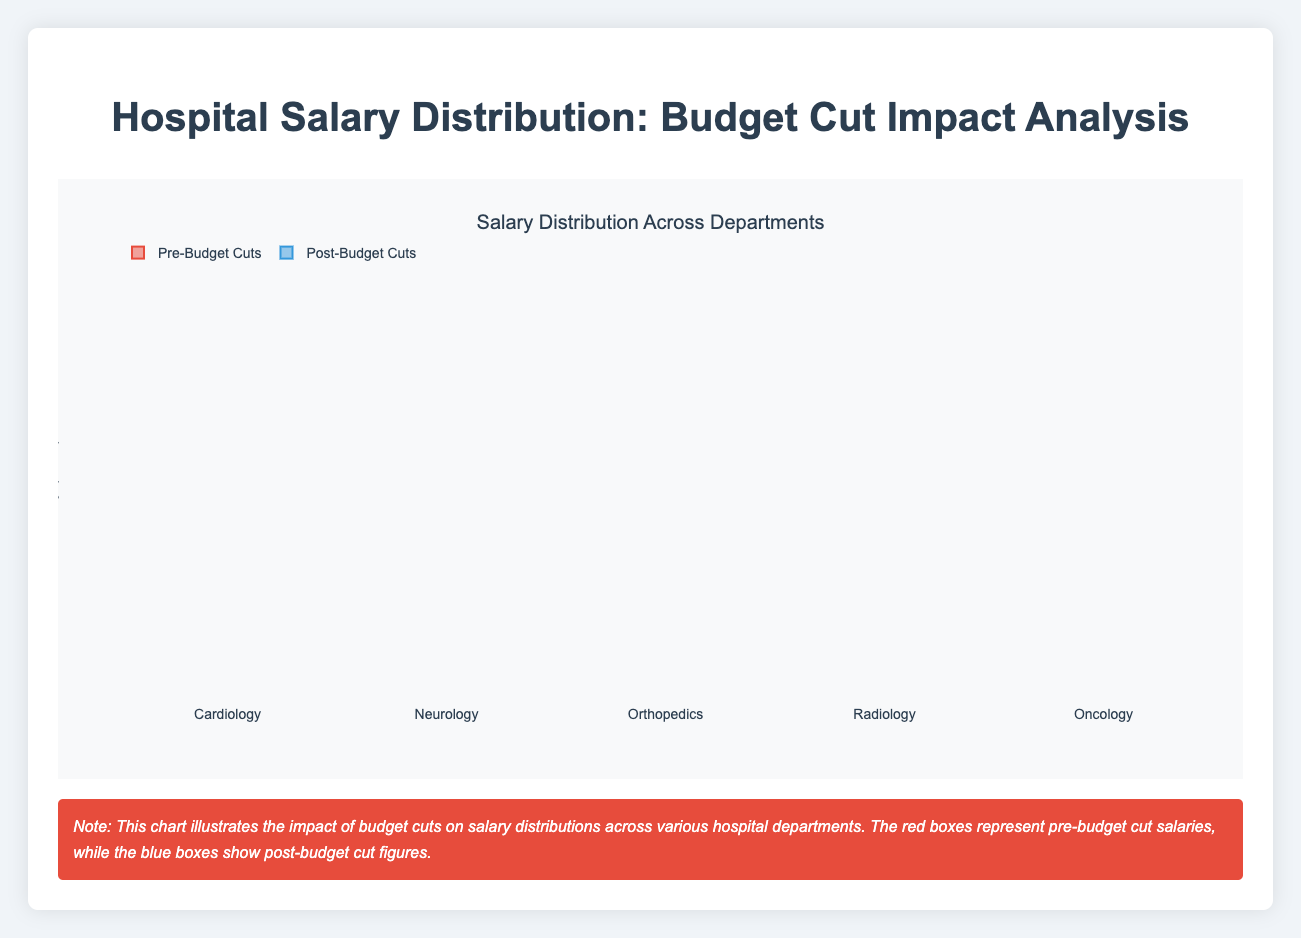Which department had the highest median salary post-budget cuts? To find the department with the highest median salary post-budget cuts, look at the middle line within the blue boxes for each department. For Orthopedics, the median line appears the highest.
Answer: Orthopedics What is the range of salaries in Cardiology post-budget cuts? The range is the difference between the highest and lowest salaries within the blue box for Cardiology. The highest salary is around 89,000, and the lowest is around 82,000. So, the range is 89,000 - 82,000.
Answer: 7,000 Did any department see an increase in salaries post-budget cuts? By comparing the positions of the red and blue boxes for each department, none of the departments have blue boxes consistently above the red boxes, indicating no increase in salary.
Answer: No Which department experienced the greatest reduction in the median salary due to budget cuts? To find the greatest reduction, compare the difference in median salaries (middle lines of the boxes) before and after budget cuts for each department. Orthopedics has one of the most noticeable reductions.
Answer: Orthopedics What is the interquartile range (IQR) for Neurology pre-budget cuts? IQR is calculated as the difference between the third quartile (top edge of the red box) and the first quartile (bottom edge of the red box) for Neurology. The third quartile is around 84,500, and the first quartile is around 78,000. So, the IQR is 84,500 - 78,000.
Answer: 6,500 Which department shows the smallest decrease in median salary post-budget cuts? To determine the smallest decrease, observe the median (middle line of the box) before and after budget cuts. Oncology shows a relatively smaller drop compared to other departments.
Answer: Oncology Is there any department where the range of salaries stayed the same after budget cuts? Compare the range (difference between the highest and lowest whiskers) of the red boxes and blue boxes for each department. Cardiology has similar ranges before and after budget cuts.
Answer: Cardiology What is the median salary for Radiology pre-budget cuts? The median salary is the middle line within the red box for Radiology. It is indicated around 73,000.
Answer: 73,000 How much is the reduction in the upper quartile (75th percentile) for Orthopedics post-budget cuts? The upper quartile before the cuts is about 98,000, and after the cuts, it is about 94,000. The reduction is 98,000 - 94,000.
Answer: 4,000 